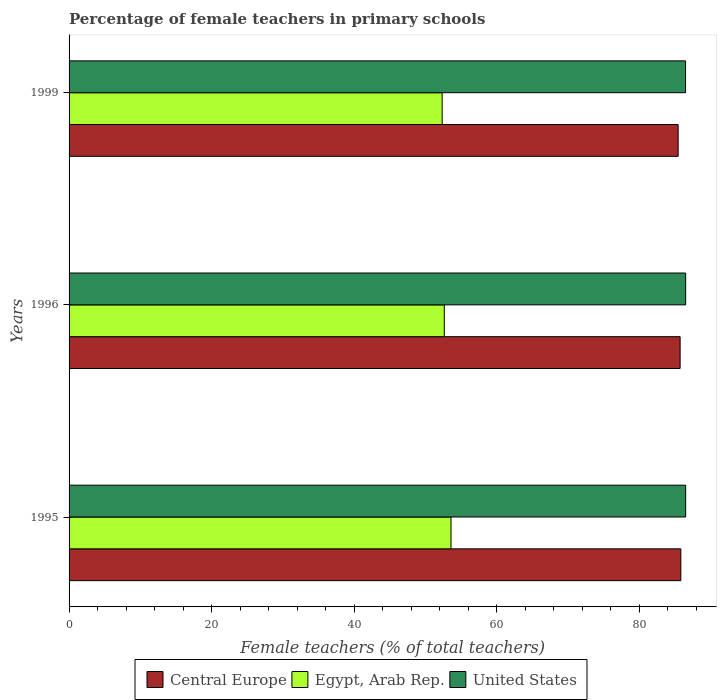Are the number of bars on each tick of the Y-axis equal?
Your response must be concise. Yes. How many bars are there on the 2nd tick from the top?
Your response must be concise. 3. What is the percentage of female teachers in Central Europe in 1995?
Provide a succinct answer. 85.8. Across all years, what is the maximum percentage of female teachers in Central Europe?
Provide a short and direct response. 85.8. Across all years, what is the minimum percentage of female teachers in Central Europe?
Provide a succinct answer. 85.43. In which year was the percentage of female teachers in Central Europe maximum?
Provide a succinct answer. 1995. In which year was the percentage of female teachers in United States minimum?
Your response must be concise. 1999. What is the total percentage of female teachers in United States in the graph?
Your answer should be compact. 259.43. What is the difference between the percentage of female teachers in Egypt, Arab Rep. in 1995 and that in 1999?
Offer a terse response. 1.24. What is the difference between the percentage of female teachers in Egypt, Arab Rep. in 1996 and the percentage of female teachers in United States in 1995?
Keep it short and to the point. -33.86. What is the average percentage of female teachers in United States per year?
Your response must be concise. 86.48. In the year 1999, what is the difference between the percentage of female teachers in Egypt, Arab Rep. and percentage of female teachers in Central Europe?
Provide a short and direct response. -33.1. What is the ratio of the percentage of female teachers in Central Europe in 1995 to that in 1999?
Keep it short and to the point. 1. What is the difference between the highest and the second highest percentage of female teachers in United States?
Keep it short and to the point. 3.0000000023733264e-5. What is the difference between the highest and the lowest percentage of female teachers in United States?
Offer a terse response. 0.01. In how many years, is the percentage of female teachers in Central Europe greater than the average percentage of female teachers in Central Europe taken over all years?
Provide a succinct answer. 2. What does the 3rd bar from the top in 1999 represents?
Ensure brevity in your answer.  Central Europe. What does the 2nd bar from the bottom in 1999 represents?
Your answer should be very brief. Egypt, Arab Rep. Is it the case that in every year, the sum of the percentage of female teachers in Egypt, Arab Rep. and percentage of female teachers in Central Europe is greater than the percentage of female teachers in United States?
Offer a terse response. Yes. How many bars are there?
Provide a short and direct response. 9. What is the difference between two consecutive major ticks on the X-axis?
Your response must be concise. 20. Are the values on the major ticks of X-axis written in scientific E-notation?
Keep it short and to the point. No. Does the graph contain any zero values?
Offer a very short reply. No. Where does the legend appear in the graph?
Your answer should be compact. Bottom center. What is the title of the graph?
Your answer should be compact. Percentage of female teachers in primary schools. Does "Korea (Democratic)" appear as one of the legend labels in the graph?
Provide a short and direct response. No. What is the label or title of the X-axis?
Keep it short and to the point. Female teachers (% of total teachers). What is the label or title of the Y-axis?
Your answer should be very brief. Years. What is the Female teachers (% of total teachers) of Central Europe in 1995?
Make the answer very short. 85.8. What is the Female teachers (% of total teachers) in Egypt, Arab Rep. in 1995?
Make the answer very short. 53.57. What is the Female teachers (% of total teachers) of United States in 1995?
Make the answer very short. 86.48. What is the Female teachers (% of total teachers) of Central Europe in 1996?
Provide a succinct answer. 85.7. What is the Female teachers (% of total teachers) in Egypt, Arab Rep. in 1996?
Offer a terse response. 52.63. What is the Female teachers (% of total teachers) of United States in 1996?
Your answer should be very brief. 86.48. What is the Female teachers (% of total teachers) in Central Europe in 1999?
Keep it short and to the point. 85.43. What is the Female teachers (% of total teachers) in Egypt, Arab Rep. in 1999?
Your answer should be compact. 52.33. What is the Female teachers (% of total teachers) in United States in 1999?
Your answer should be compact. 86.47. Across all years, what is the maximum Female teachers (% of total teachers) of Central Europe?
Ensure brevity in your answer.  85.8. Across all years, what is the maximum Female teachers (% of total teachers) of Egypt, Arab Rep.?
Offer a terse response. 53.57. Across all years, what is the maximum Female teachers (% of total teachers) of United States?
Give a very brief answer. 86.48. Across all years, what is the minimum Female teachers (% of total teachers) in Central Europe?
Offer a terse response. 85.43. Across all years, what is the minimum Female teachers (% of total teachers) in Egypt, Arab Rep.?
Offer a very short reply. 52.33. Across all years, what is the minimum Female teachers (% of total teachers) in United States?
Keep it short and to the point. 86.47. What is the total Female teachers (% of total teachers) in Central Europe in the graph?
Give a very brief answer. 256.94. What is the total Female teachers (% of total teachers) of Egypt, Arab Rep. in the graph?
Your answer should be compact. 158.53. What is the total Female teachers (% of total teachers) of United States in the graph?
Offer a very short reply. 259.43. What is the difference between the Female teachers (% of total teachers) in Central Europe in 1995 and that in 1996?
Ensure brevity in your answer.  0.1. What is the difference between the Female teachers (% of total teachers) in Egypt, Arab Rep. in 1995 and that in 1996?
Your answer should be very brief. 0.94. What is the difference between the Female teachers (% of total teachers) of Central Europe in 1995 and that in 1999?
Keep it short and to the point. 0.38. What is the difference between the Female teachers (% of total teachers) in Egypt, Arab Rep. in 1995 and that in 1999?
Offer a very short reply. 1.24. What is the difference between the Female teachers (% of total teachers) in United States in 1995 and that in 1999?
Keep it short and to the point. 0.01. What is the difference between the Female teachers (% of total teachers) in Central Europe in 1996 and that in 1999?
Your answer should be compact. 0.28. What is the difference between the Female teachers (% of total teachers) in Egypt, Arab Rep. in 1996 and that in 1999?
Provide a succinct answer. 0.3. What is the difference between the Female teachers (% of total teachers) in United States in 1996 and that in 1999?
Make the answer very short. 0.01. What is the difference between the Female teachers (% of total teachers) of Central Europe in 1995 and the Female teachers (% of total teachers) of Egypt, Arab Rep. in 1996?
Provide a short and direct response. 33.18. What is the difference between the Female teachers (% of total teachers) of Central Europe in 1995 and the Female teachers (% of total teachers) of United States in 1996?
Give a very brief answer. -0.68. What is the difference between the Female teachers (% of total teachers) in Egypt, Arab Rep. in 1995 and the Female teachers (% of total teachers) in United States in 1996?
Provide a succinct answer. -32.91. What is the difference between the Female teachers (% of total teachers) of Central Europe in 1995 and the Female teachers (% of total teachers) of Egypt, Arab Rep. in 1999?
Make the answer very short. 33.47. What is the difference between the Female teachers (% of total teachers) of Central Europe in 1995 and the Female teachers (% of total teachers) of United States in 1999?
Provide a short and direct response. -0.66. What is the difference between the Female teachers (% of total teachers) in Egypt, Arab Rep. in 1995 and the Female teachers (% of total teachers) in United States in 1999?
Offer a very short reply. -32.9. What is the difference between the Female teachers (% of total teachers) in Central Europe in 1996 and the Female teachers (% of total teachers) in Egypt, Arab Rep. in 1999?
Offer a terse response. 33.37. What is the difference between the Female teachers (% of total teachers) in Central Europe in 1996 and the Female teachers (% of total teachers) in United States in 1999?
Give a very brief answer. -0.76. What is the difference between the Female teachers (% of total teachers) of Egypt, Arab Rep. in 1996 and the Female teachers (% of total teachers) of United States in 1999?
Ensure brevity in your answer.  -33.84. What is the average Female teachers (% of total teachers) of Central Europe per year?
Offer a terse response. 85.65. What is the average Female teachers (% of total teachers) in Egypt, Arab Rep. per year?
Offer a very short reply. 52.84. What is the average Female teachers (% of total teachers) in United States per year?
Your response must be concise. 86.48. In the year 1995, what is the difference between the Female teachers (% of total teachers) of Central Europe and Female teachers (% of total teachers) of Egypt, Arab Rep.?
Ensure brevity in your answer.  32.24. In the year 1995, what is the difference between the Female teachers (% of total teachers) in Central Europe and Female teachers (% of total teachers) in United States?
Ensure brevity in your answer.  -0.68. In the year 1995, what is the difference between the Female teachers (% of total teachers) of Egypt, Arab Rep. and Female teachers (% of total teachers) of United States?
Ensure brevity in your answer.  -32.91. In the year 1996, what is the difference between the Female teachers (% of total teachers) of Central Europe and Female teachers (% of total teachers) of Egypt, Arab Rep.?
Give a very brief answer. 33.08. In the year 1996, what is the difference between the Female teachers (% of total teachers) of Central Europe and Female teachers (% of total teachers) of United States?
Give a very brief answer. -0.78. In the year 1996, what is the difference between the Female teachers (% of total teachers) of Egypt, Arab Rep. and Female teachers (% of total teachers) of United States?
Give a very brief answer. -33.86. In the year 1999, what is the difference between the Female teachers (% of total teachers) in Central Europe and Female teachers (% of total teachers) in Egypt, Arab Rep.?
Give a very brief answer. 33.1. In the year 1999, what is the difference between the Female teachers (% of total teachers) in Central Europe and Female teachers (% of total teachers) in United States?
Ensure brevity in your answer.  -1.04. In the year 1999, what is the difference between the Female teachers (% of total teachers) of Egypt, Arab Rep. and Female teachers (% of total teachers) of United States?
Offer a terse response. -34.14. What is the ratio of the Female teachers (% of total teachers) in Central Europe in 1995 to that in 1996?
Your answer should be compact. 1. What is the ratio of the Female teachers (% of total teachers) of Egypt, Arab Rep. in 1995 to that in 1996?
Provide a succinct answer. 1.02. What is the ratio of the Female teachers (% of total teachers) in Egypt, Arab Rep. in 1995 to that in 1999?
Your answer should be very brief. 1.02. What is the ratio of the Female teachers (% of total teachers) in Egypt, Arab Rep. in 1996 to that in 1999?
Provide a short and direct response. 1.01. What is the difference between the highest and the second highest Female teachers (% of total teachers) of Central Europe?
Offer a terse response. 0.1. What is the difference between the highest and the second highest Female teachers (% of total teachers) of Egypt, Arab Rep.?
Your response must be concise. 0.94. What is the difference between the highest and the lowest Female teachers (% of total teachers) in Central Europe?
Provide a succinct answer. 0.38. What is the difference between the highest and the lowest Female teachers (% of total teachers) in Egypt, Arab Rep.?
Offer a very short reply. 1.24. What is the difference between the highest and the lowest Female teachers (% of total teachers) in United States?
Give a very brief answer. 0.01. 